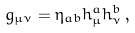Convert formula to latex. <formula><loc_0><loc_0><loc_500><loc_500>g _ { \mu \nu } = \eta _ { a b } h _ { \mu } ^ { a } h _ { \nu } ^ { b } \, ,</formula> 